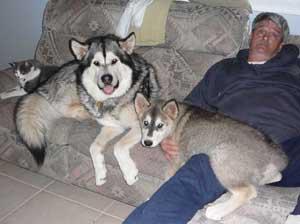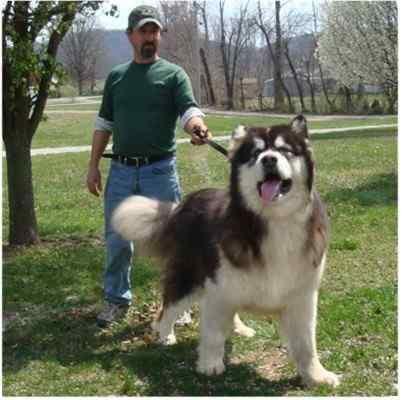The first image is the image on the left, the second image is the image on the right. For the images shown, is this caption "The left and right image contains the same number of dogs." true? Answer yes or no. No. The first image is the image on the left, the second image is the image on the right. Considering the images on both sides, is "One image shows a woman standing behind a dog standing in profile turned leftward, and a sign with a prize ribbon is upright on the ground in front of the dog." valid? Answer yes or no. No. 